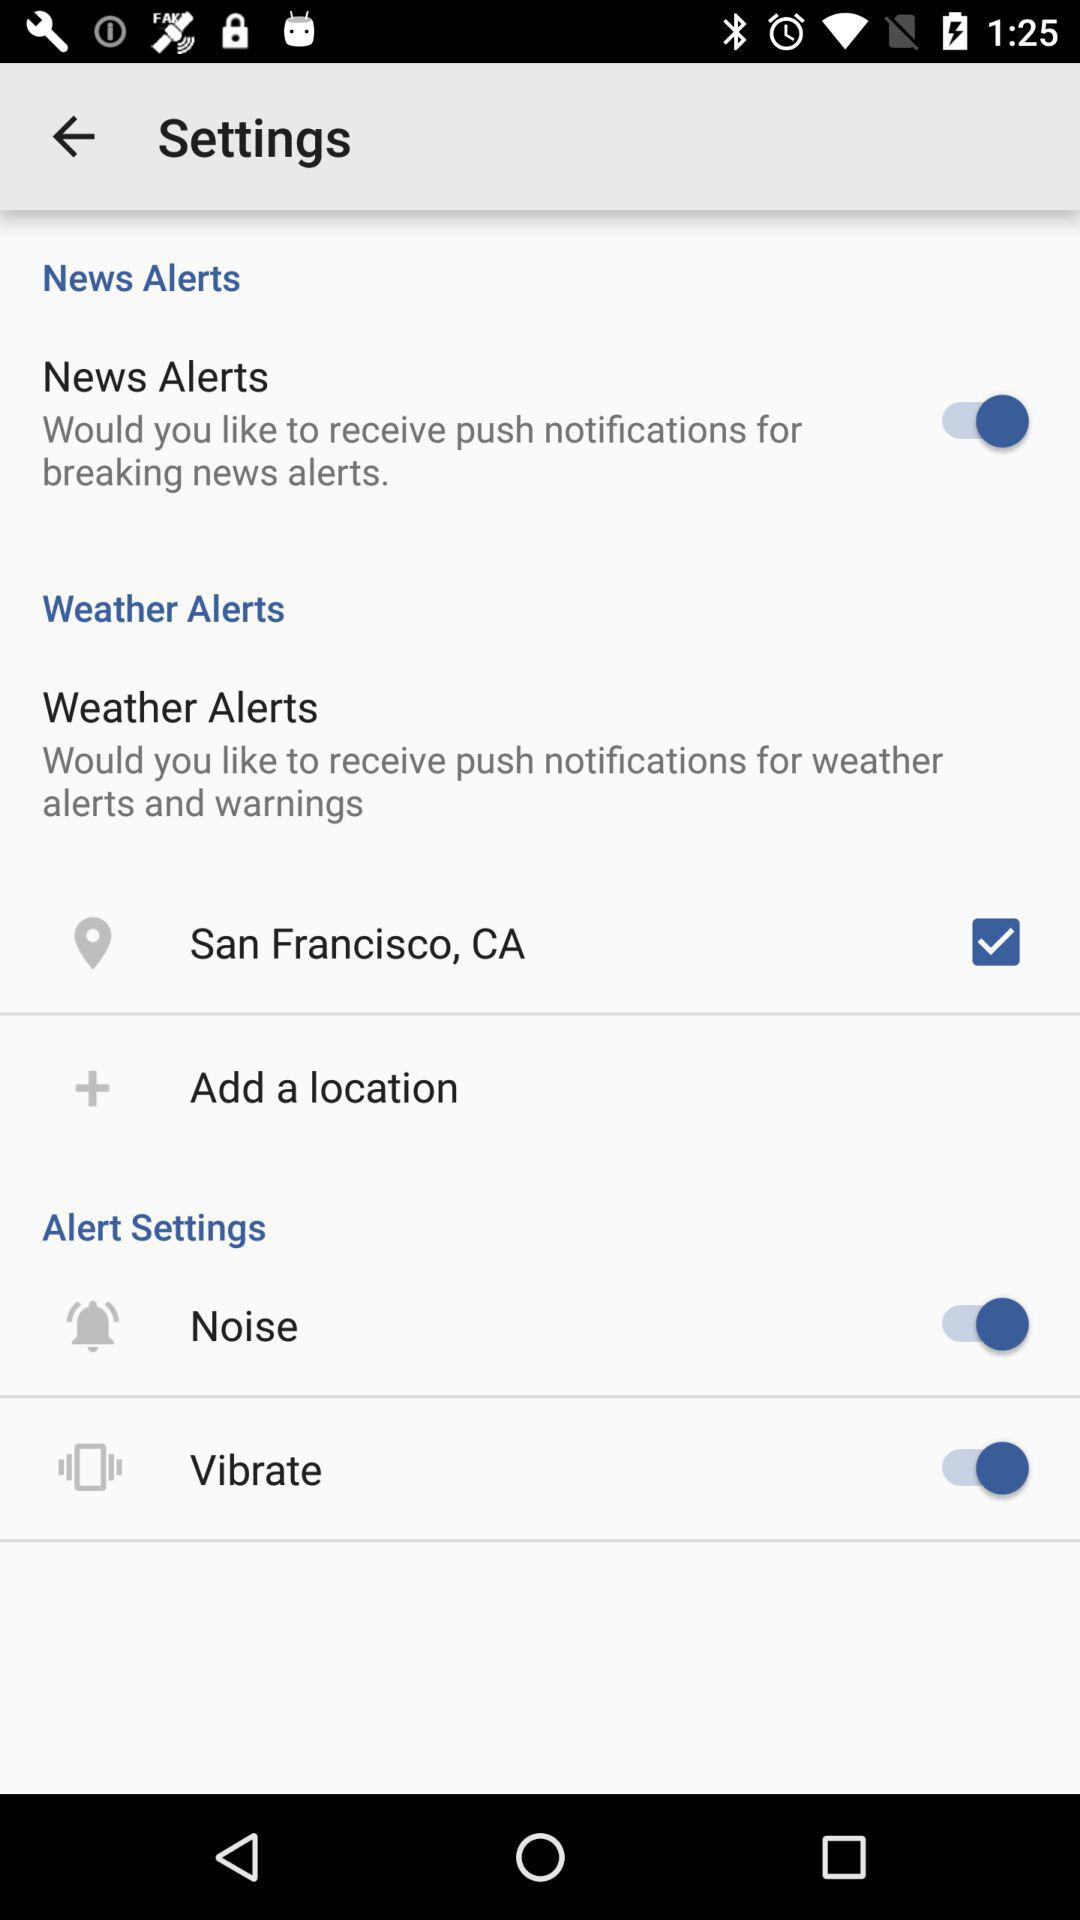How often are push notifications for breaking news alerts sent?
When the provided information is insufficient, respond with <no answer>. <no answer> 